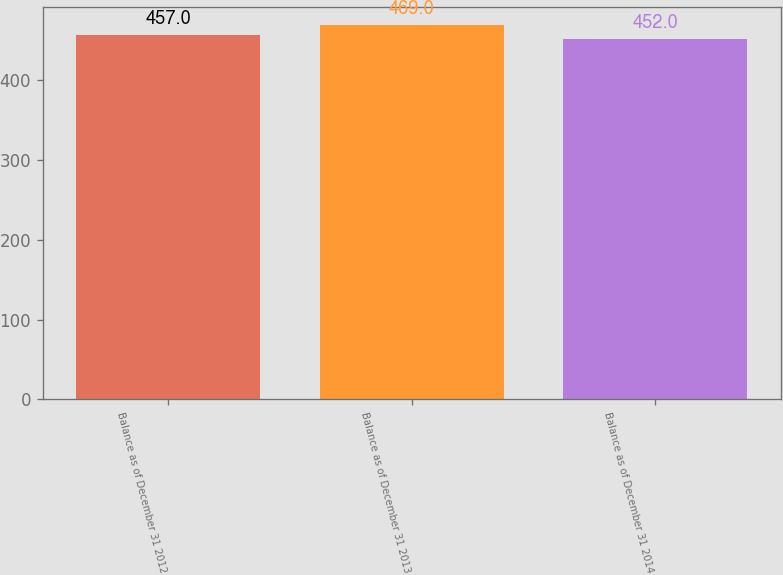<chart> <loc_0><loc_0><loc_500><loc_500><bar_chart><fcel>Balance as of December 31 2012<fcel>Balance as of December 31 2013<fcel>Balance as of December 31 2014<nl><fcel>457<fcel>469<fcel>452<nl></chart> 